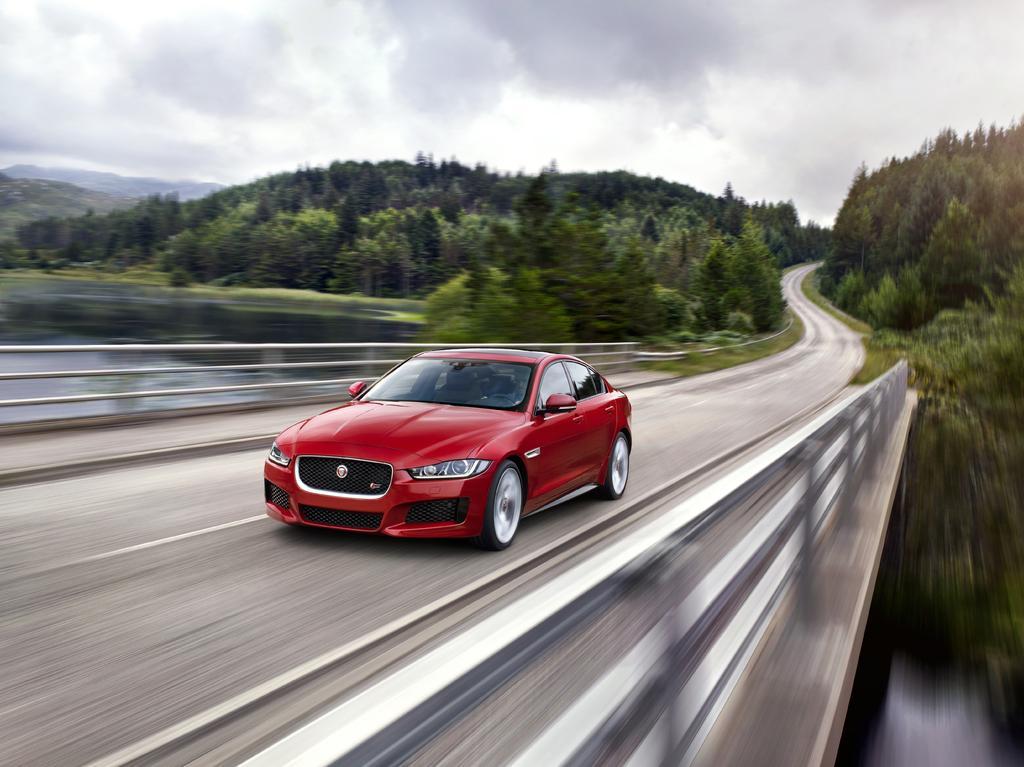In one or two sentences, can you explain what this image depicts? In this image there is a fast moving car on the bridge. Below the bridge there is water. In the background there are trees on either side of the road. At the top there is the sky. 